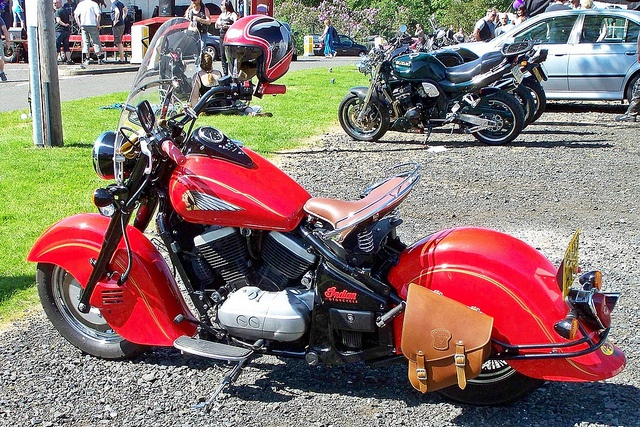Describe the objects in this image and their specific colors. I can see motorcycle in navy, black, red, lightgray, and gray tones, motorcycle in navy, black, gray, darkgray, and lightgray tones, car in navy, white, lightblue, darkgray, and gray tones, people in navy, black, gray, darkgray, and white tones, and people in navy, black, darkgray, lightgray, and gray tones in this image. 